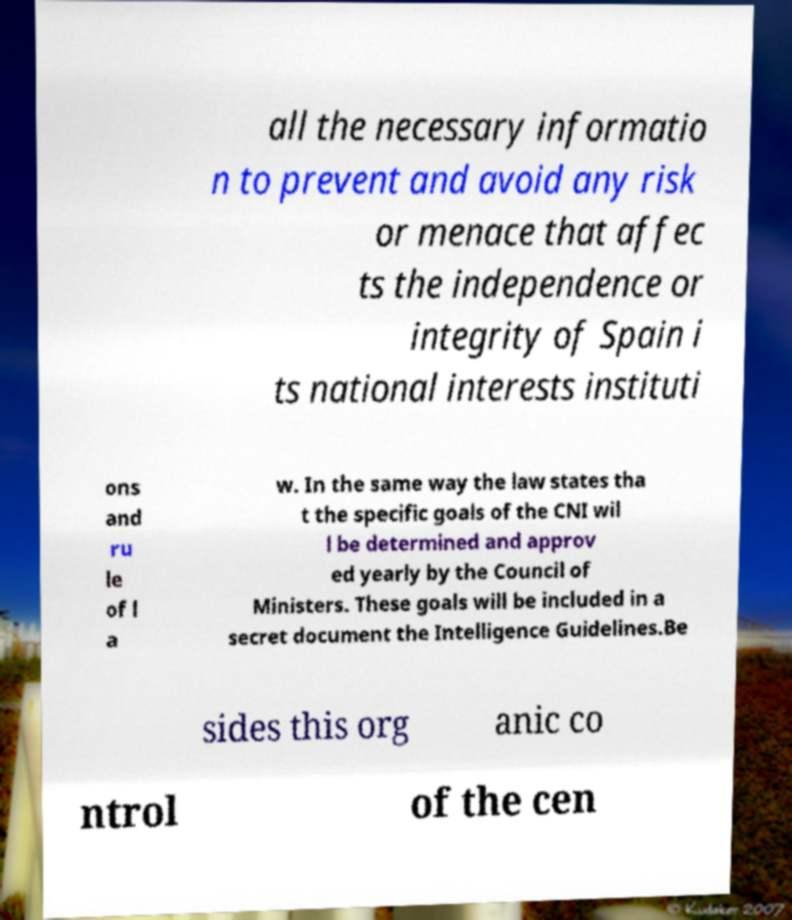Please read and relay the text visible in this image. What does it say? all the necessary informatio n to prevent and avoid any risk or menace that affec ts the independence or integrity of Spain i ts national interests instituti ons and ru le of l a w. In the same way the law states tha t the specific goals of the CNI wil l be determined and approv ed yearly by the Council of Ministers. These goals will be included in a secret document the Intelligence Guidelines.Be sides this org anic co ntrol of the cen 